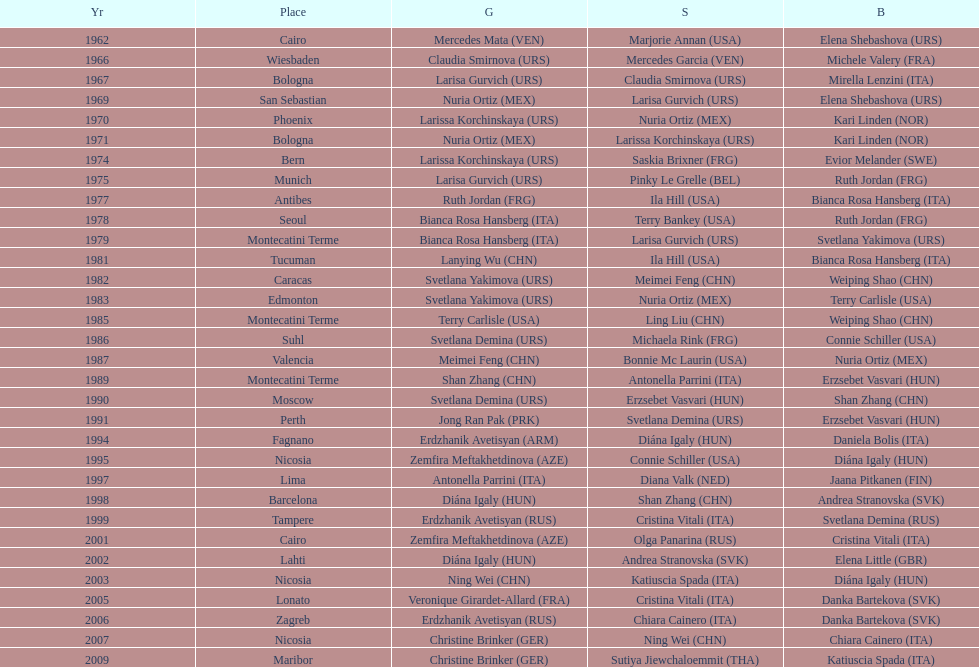Which country has the most bronze medals? Italy. 